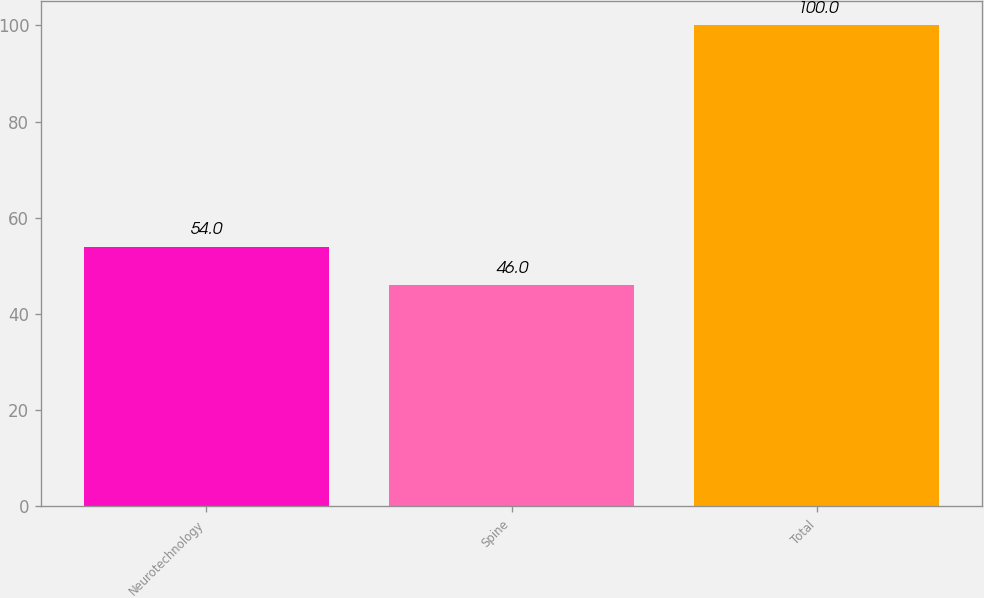Convert chart to OTSL. <chart><loc_0><loc_0><loc_500><loc_500><bar_chart><fcel>Neurotechnology<fcel>Spine<fcel>Total<nl><fcel>54<fcel>46<fcel>100<nl></chart> 